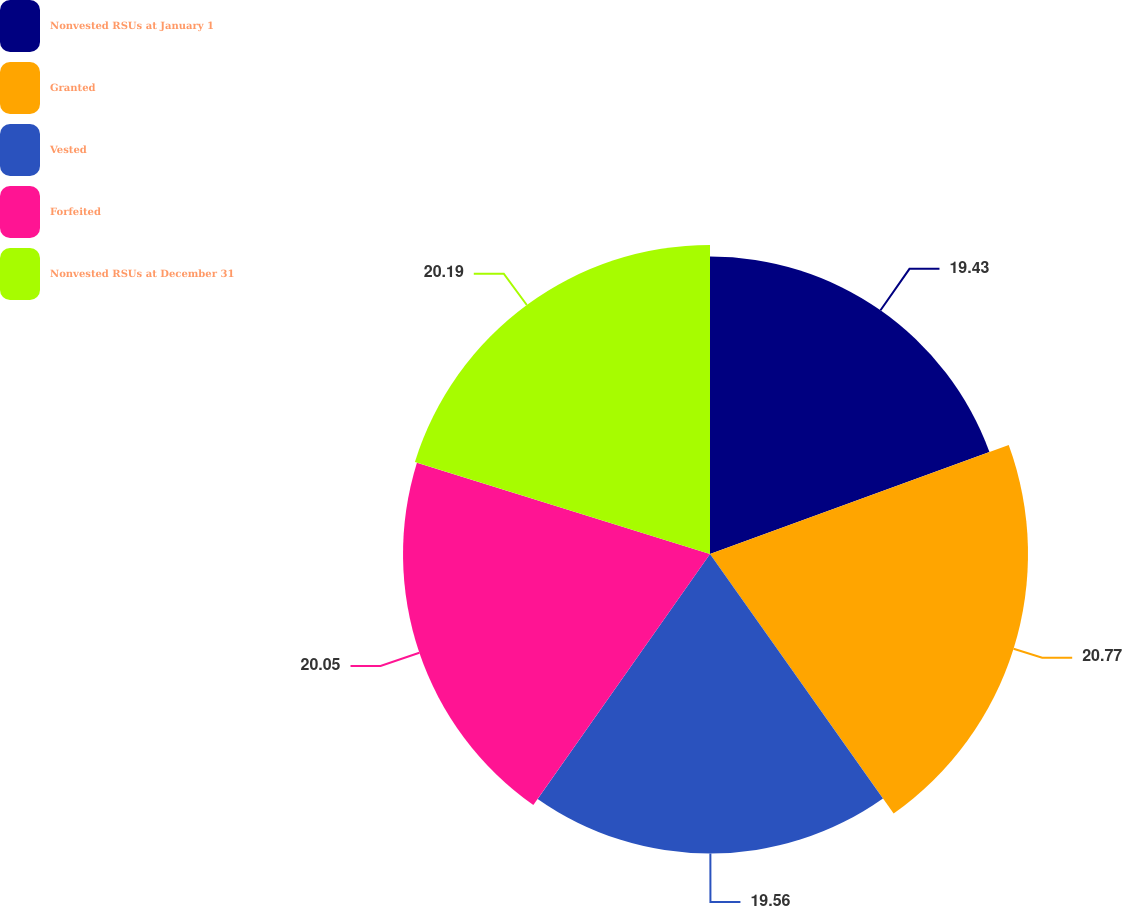Convert chart. <chart><loc_0><loc_0><loc_500><loc_500><pie_chart><fcel>Nonvested RSUs at January 1<fcel>Granted<fcel>Vested<fcel>Forfeited<fcel>Nonvested RSUs at December 31<nl><fcel>19.43%<fcel>20.77%<fcel>19.56%<fcel>20.05%<fcel>20.19%<nl></chart> 